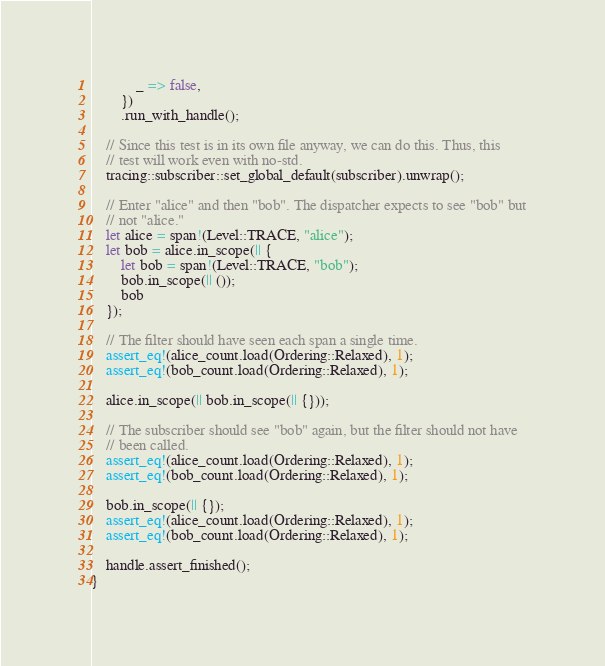<code> <loc_0><loc_0><loc_500><loc_500><_Rust_>            _ => false,
        })
        .run_with_handle();

    // Since this test is in its own file anyway, we can do this. Thus, this
    // test will work even with no-std.
    tracing::subscriber::set_global_default(subscriber).unwrap();

    // Enter "alice" and then "bob". The dispatcher expects to see "bob" but
    // not "alice."
    let alice = span!(Level::TRACE, "alice");
    let bob = alice.in_scope(|| {
        let bob = span!(Level::TRACE, "bob");
        bob.in_scope(|| ());
        bob
    });

    // The filter should have seen each span a single time.
    assert_eq!(alice_count.load(Ordering::Relaxed), 1);
    assert_eq!(bob_count.load(Ordering::Relaxed), 1);

    alice.in_scope(|| bob.in_scope(|| {}));

    // The subscriber should see "bob" again, but the filter should not have
    // been called.
    assert_eq!(alice_count.load(Ordering::Relaxed), 1);
    assert_eq!(bob_count.load(Ordering::Relaxed), 1);

    bob.in_scope(|| {});
    assert_eq!(alice_count.load(Ordering::Relaxed), 1);
    assert_eq!(bob_count.load(Ordering::Relaxed), 1);

    handle.assert_finished();
}
</code> 